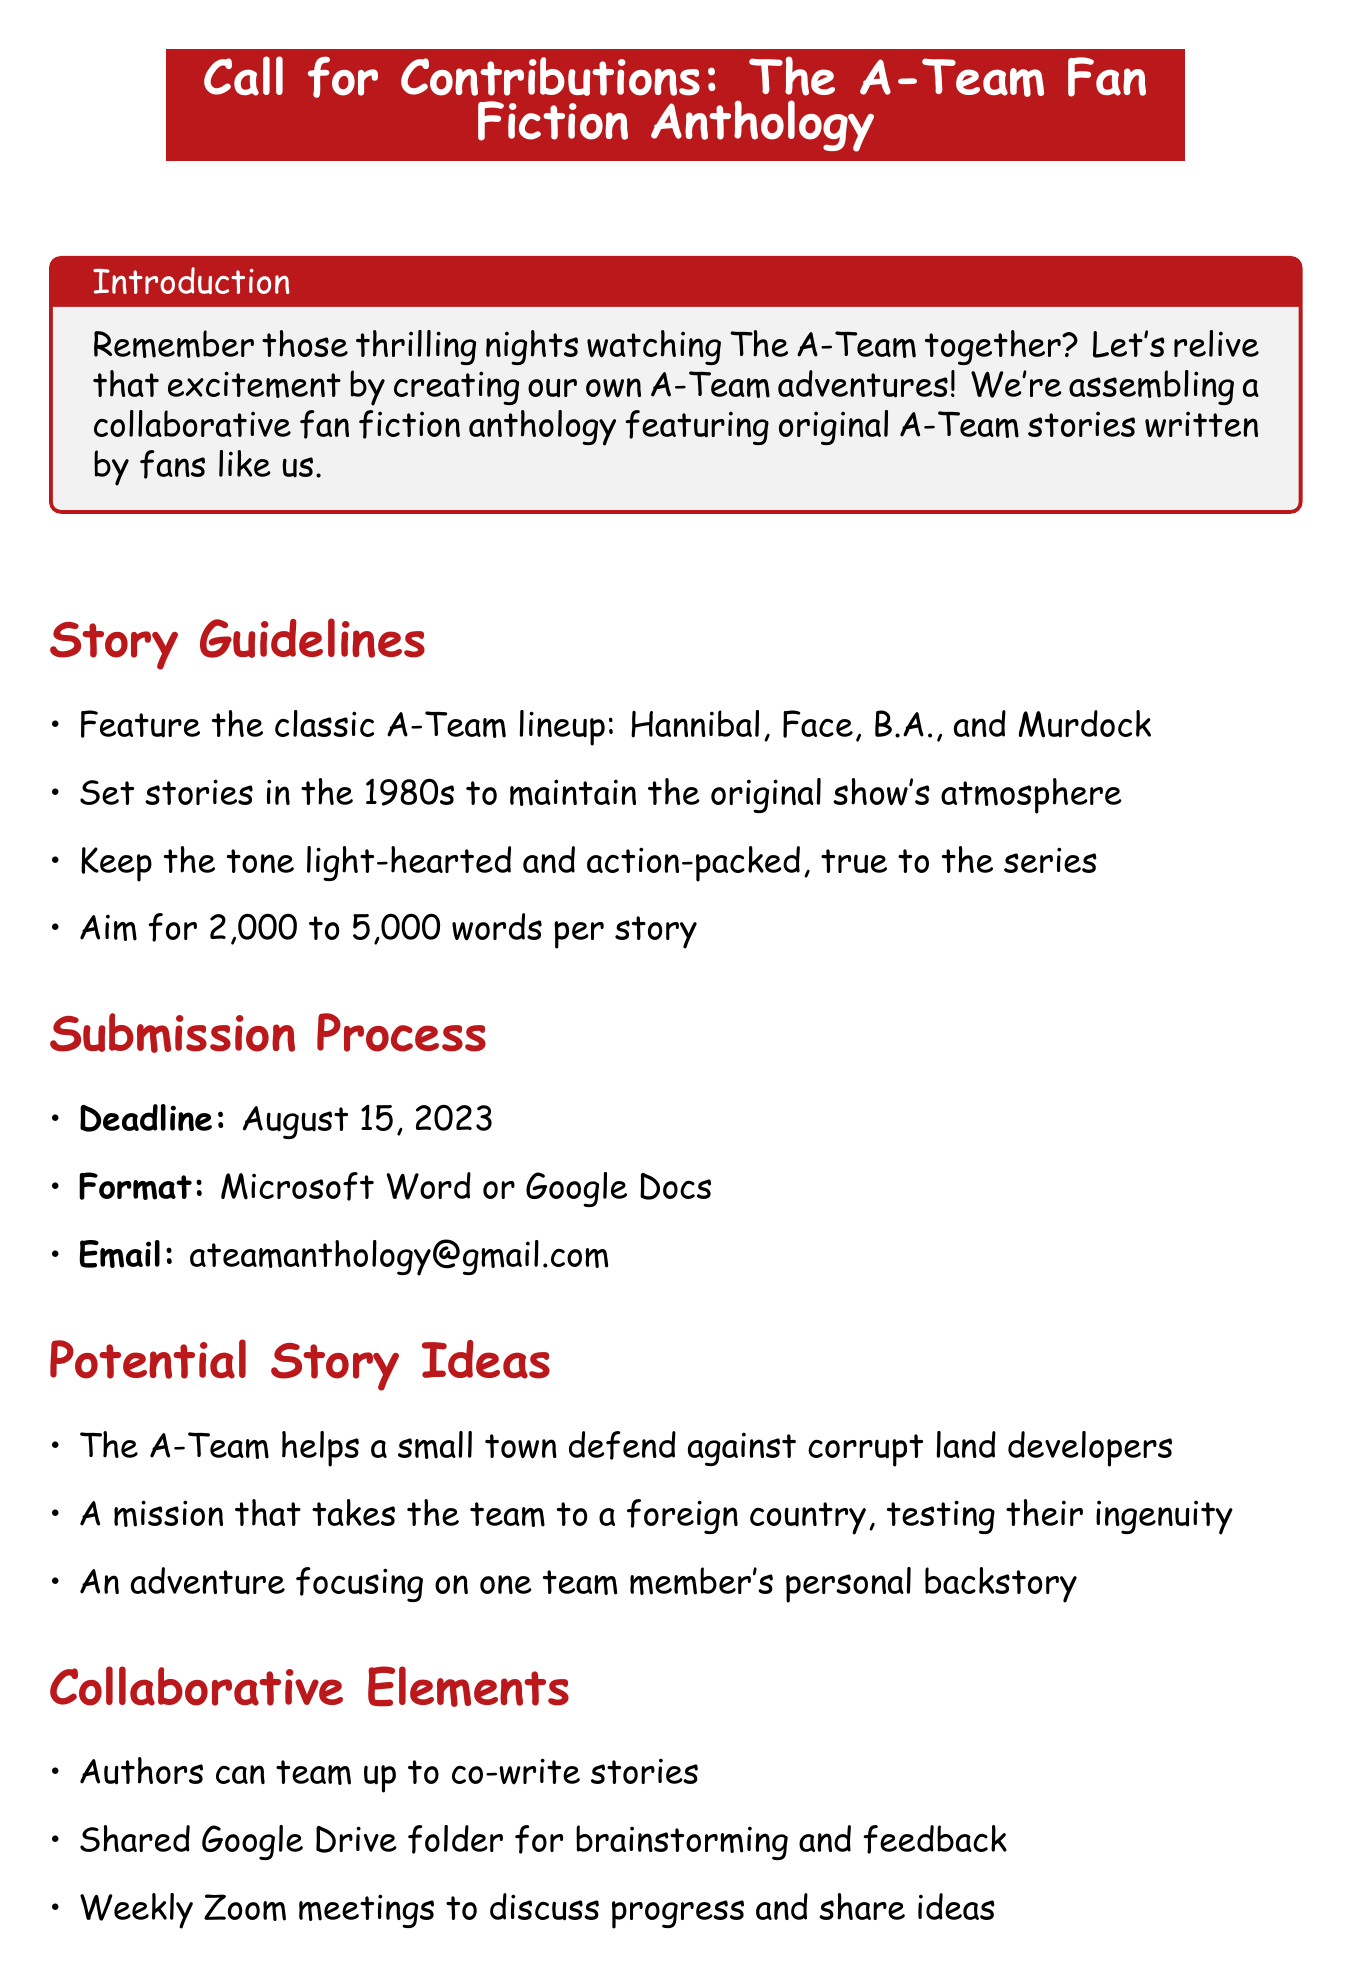what is the subject of the memo? The subject indicates the main focus of the document, which is about contributions for a collaborative project.
Answer: Call for Contributions: The A-Team Fan Fiction Anthology who is the project coordinator? The project coordinator is the person responsible for overseeing the project and is named in the contact information section.
Answer: Sarah Johnson what is the submission deadline? The submission deadline specifies the final date for sending in contributions to the anthology.
Answer: August 15, 2023 what formats are accepted for story submissions? The formats detail the file types contributors must use to submit their stories.
Answer: Microsoft Word or Google Docs how many words should each story aim for? The word count range gives writers guidance on the length of their stories for the anthology.
Answer: 2,000 to 5,000 words what is one potential story idea? This question looks for an example of the creative prompts provided to inspire contributors.
Answer: The A-Team helps a small town defend against corrupt land developers what is the publication format? The publication format outlines how the finished anthology will be made available to readers.
Answer: Digital ebook and limited print run what do the proceeds from the anthology support? This question identifies the cause that will benefit from the sales of the anthology.
Answer: The Soldiers Project, supporting veterans' mental health who can authors collaborate with? This question aims to clarify if authors have the option to work together on stories.
Answer: Other authors 